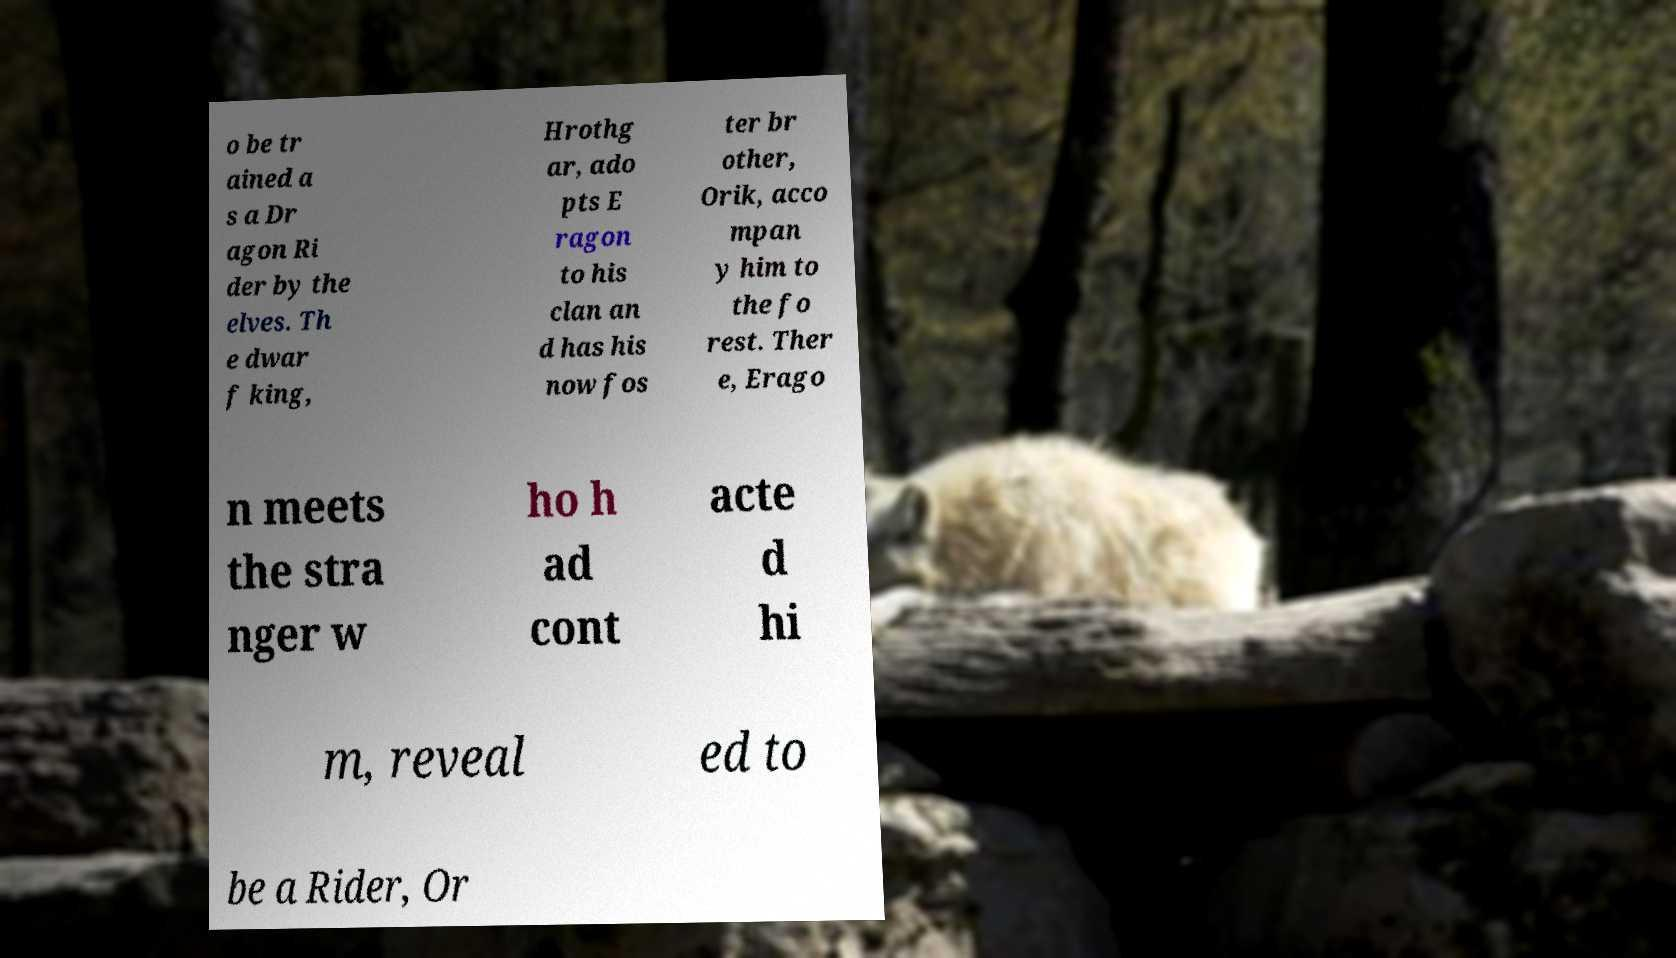Please identify and transcribe the text found in this image. o be tr ained a s a Dr agon Ri der by the elves. Th e dwar f king, Hrothg ar, ado pts E ragon to his clan an d has his now fos ter br other, Orik, acco mpan y him to the fo rest. Ther e, Erago n meets the stra nger w ho h ad cont acte d hi m, reveal ed to be a Rider, Or 